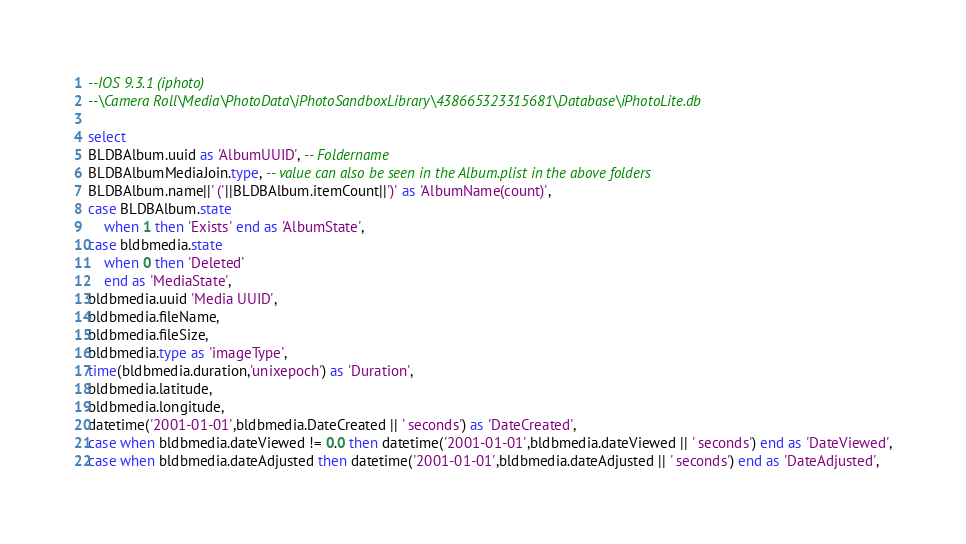Convert code to text. <code><loc_0><loc_0><loc_500><loc_500><_SQL_>--IOS 9.3.1 (iphoto)
--\Camera Roll\Media\PhotoData\iPhotoSandboxLibrary\438665323315681\Database\iPhotoLite.db

select 
BLDBAlbum.uuid as 'AlbumUUID', -- Foldername
BLDBAlbumMediaJoin.type, -- value can also be seen in the Album.plist in the above folders
BLDBAlbum.name||' ('||BLDBAlbum.itemCount||')' as 'AlbumName(count)',
case BLDBAlbum.state 
	when 1 then 'Exists' end as 'AlbumState', 
case bldbmedia.state 
	when 0 then 'Deleted'
	end as 'MediaState',
bldbmedia.uuid 'Media UUID',
bldbmedia.fileName,
bldbmedia.fileSize,
bldbmedia.type as 'imageType',
time(bldbmedia.duration,'unixepoch') as 'Duration',
bldbmedia.latitude,
bldbmedia.longitude,
datetime('2001-01-01',bldbmedia.DateCreated || ' seconds') as 'DateCreated',
case when bldbmedia.dateViewed != 0.0 then datetime('2001-01-01',bldbmedia.dateViewed || ' seconds') end as 'DateViewed',
case when bldbmedia.dateAdjusted then datetime('2001-01-01',bldbmedia.dateAdjusted || ' seconds') end as 'DateAdjusted',</code> 